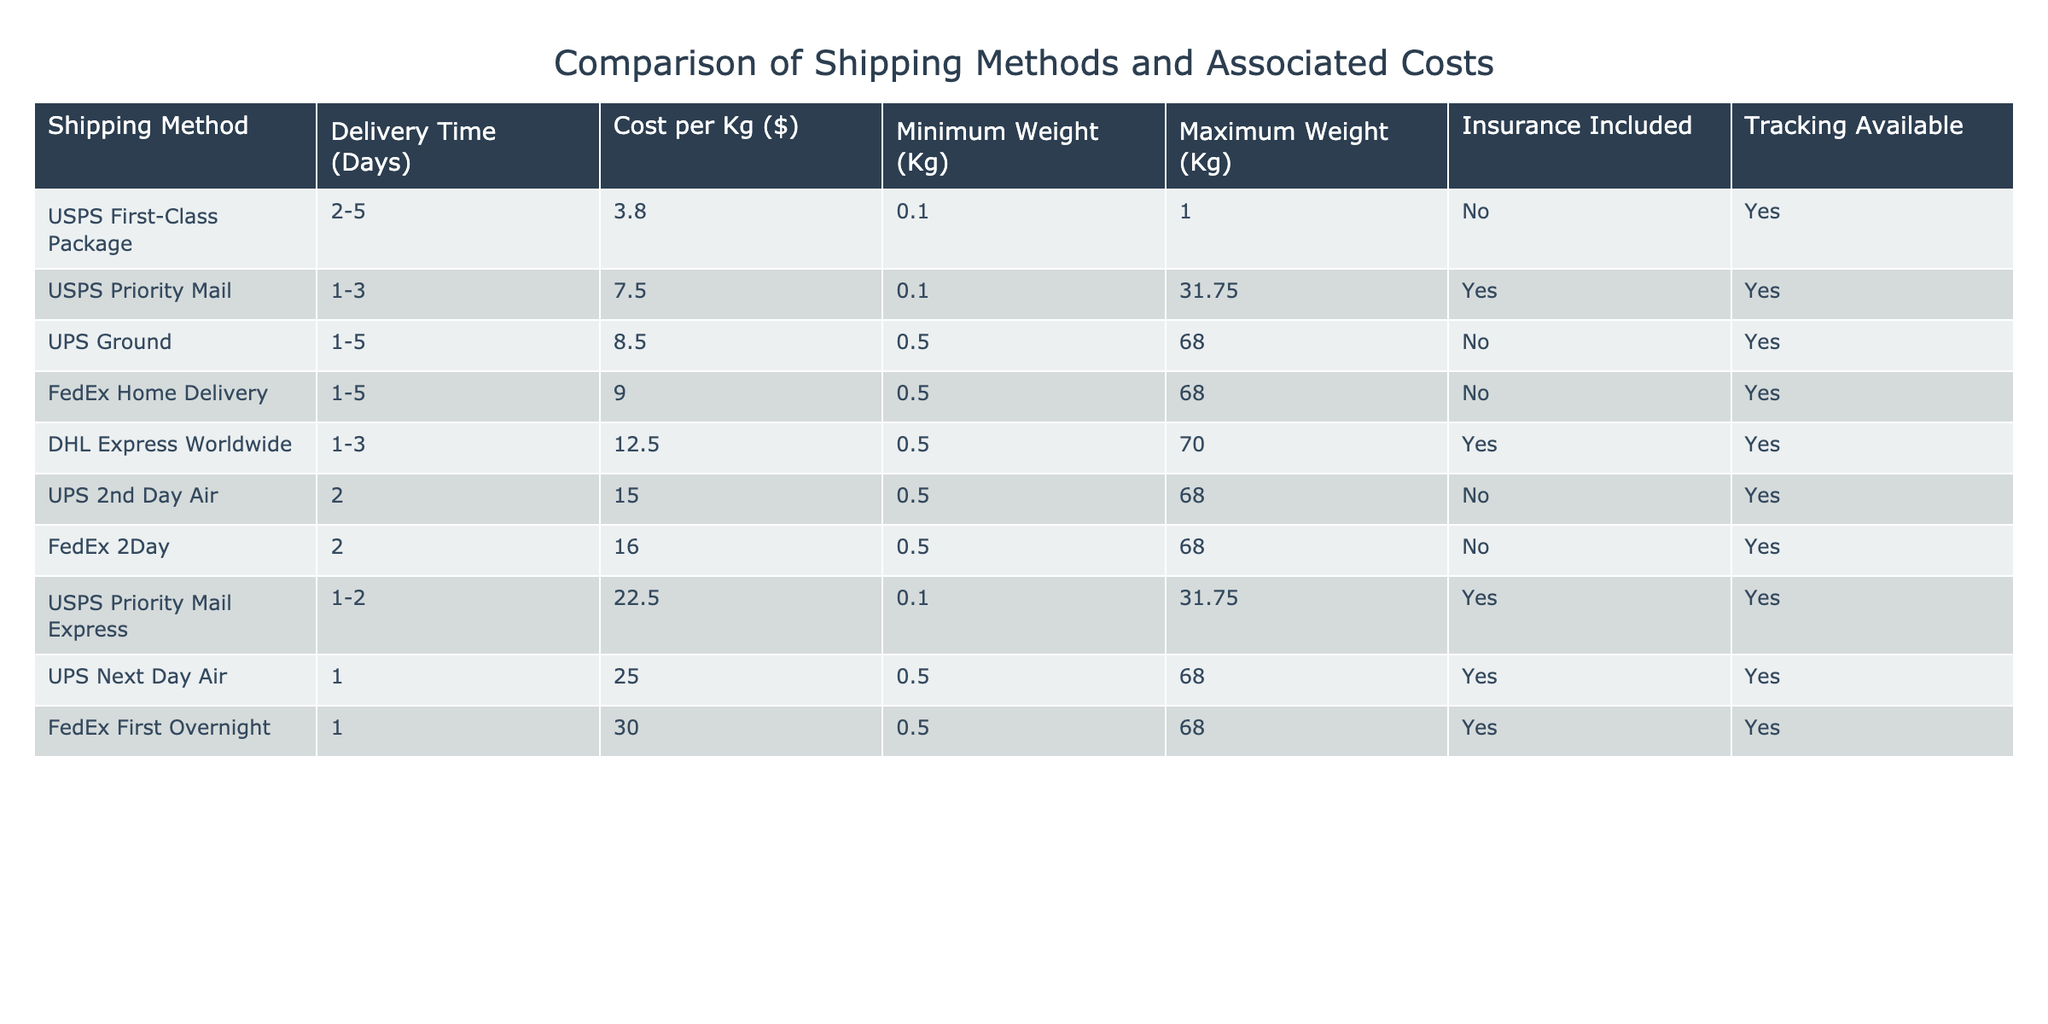What is the delivery time for USPS Priority Mail? The table shows that the delivery time for USPS Priority Mail is 1-3 days.
Answer: 1-3 days Which shipping method has the highest cost per kilogram? According to the table, FedEx First Overnight has the highest cost per kilogram at $30.00.
Answer: $30.00 Can UPS Ground ship packages weighing 100 kg? The maximum weight for UPS Ground is 68 kg, so it cannot ship packages weighing 100 kg.
Answer: No What is the average delivery time of all shipping methods listed? The delivery times are 2-5, 1-3, 1-5, 1-5, 1-3, 2, 2, 1-2, 1, and 1. Taking the average value of these ranges gives roughly 2 days overall.
Answer: 2 days Which shipping method provides insurance? The table states that USPS Priority Mail, USPS Priority Mail Express, DHL Express Worldwide, and UPS Next Day Air include insurance.
Answer: USPS Priority Mail, USPS Priority Mail Express, DHL Express Worldwide, UPS Next Day Air What is the difference in cost per kg between the cheapest and most expensive shipping methods? The cheapest method is USPS First-Class Package at $3.80, and the most expensive is FedEx First Overnight at $30.00. The difference is $30.00 - $3.80 = $26.20.
Answer: $26.20 How many shipping methods allow tracking? The table shows that all shipping methods listed provide tracking, so the total count is 9.
Answer: 9 Which shipping method has the shortest delivery time? The table indicates that UPS Next Day Air has the shortest delivery time of 1 day.
Answer: 1 day Is there any shipping method with a minimum weight requirement of less than 0.5 kg? Yes, both USPS First-Class Package and USPS Priority Mail have a minimum weight requirement of 0.1 kg.
Answer: Yes What is the cost per kg for DHL Express Worldwide? The table lists the cost per kg for DHL Express Worldwide as $12.50.
Answer: $12.50 